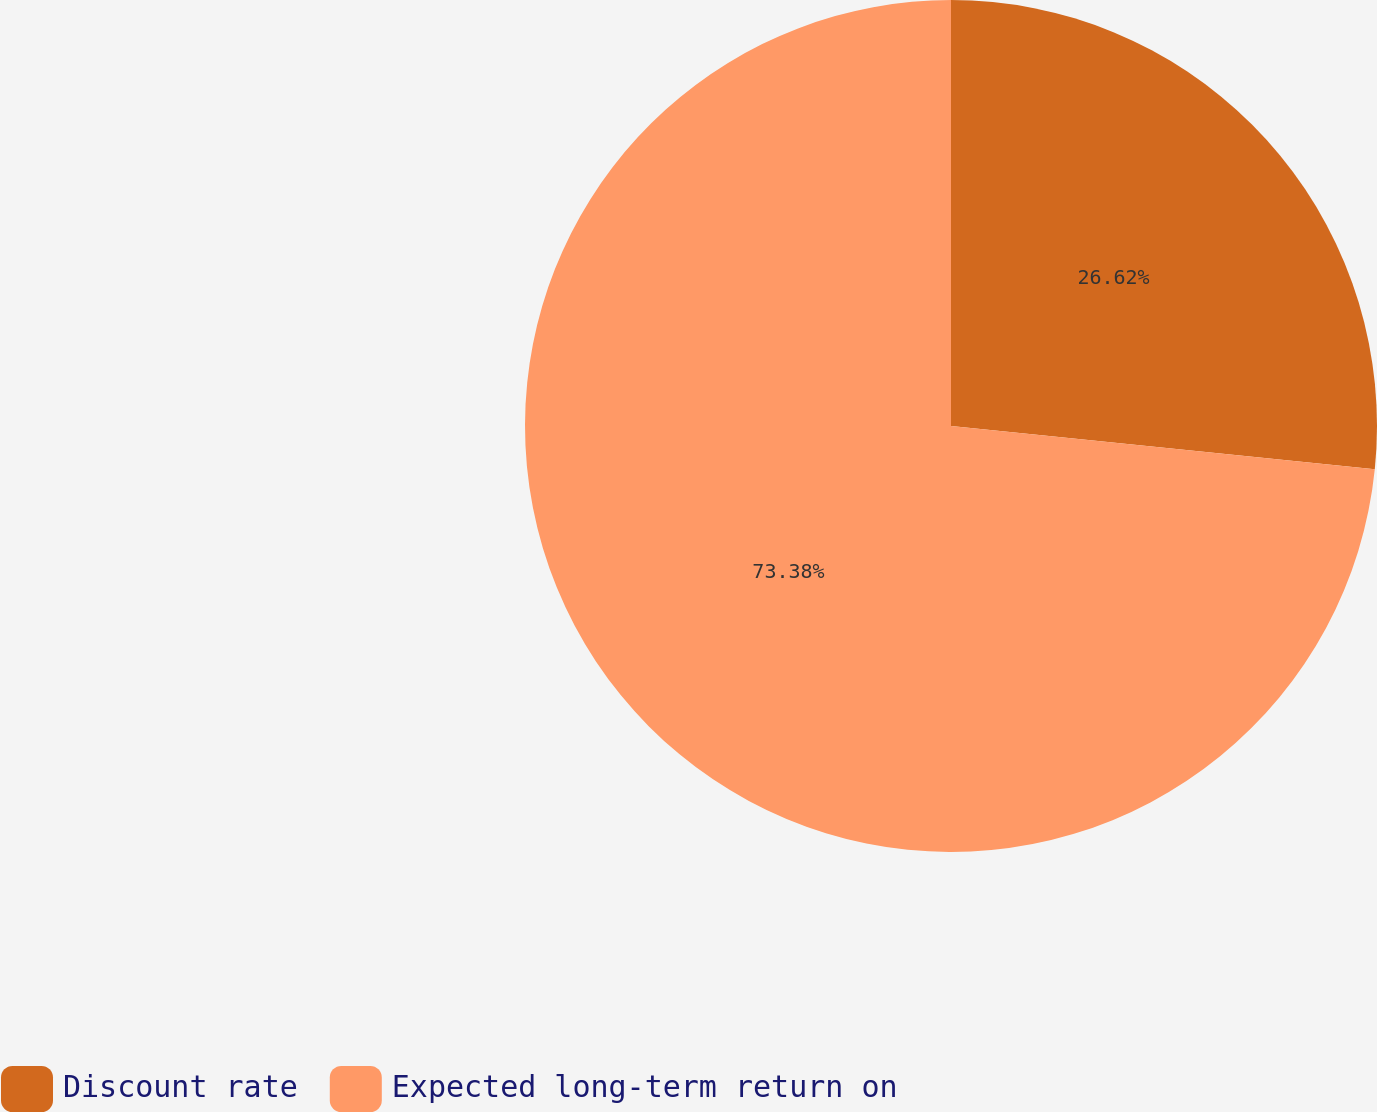Convert chart to OTSL. <chart><loc_0><loc_0><loc_500><loc_500><pie_chart><fcel>Discount rate<fcel>Expected long-term return on<nl><fcel>26.62%<fcel>73.38%<nl></chart> 